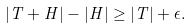Convert formula to latex. <formula><loc_0><loc_0><loc_500><loc_500>| T + H | - | H | \geq | T | + \epsilon .</formula> 